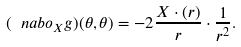Convert formula to latex. <formula><loc_0><loc_0><loc_500><loc_500>( \ n a b o _ { X } g ) ( \theta , \theta ) = - 2 \frac { X \cdot ( r ) } { r } \cdot \frac { 1 } { r ^ { 2 } } .</formula> 